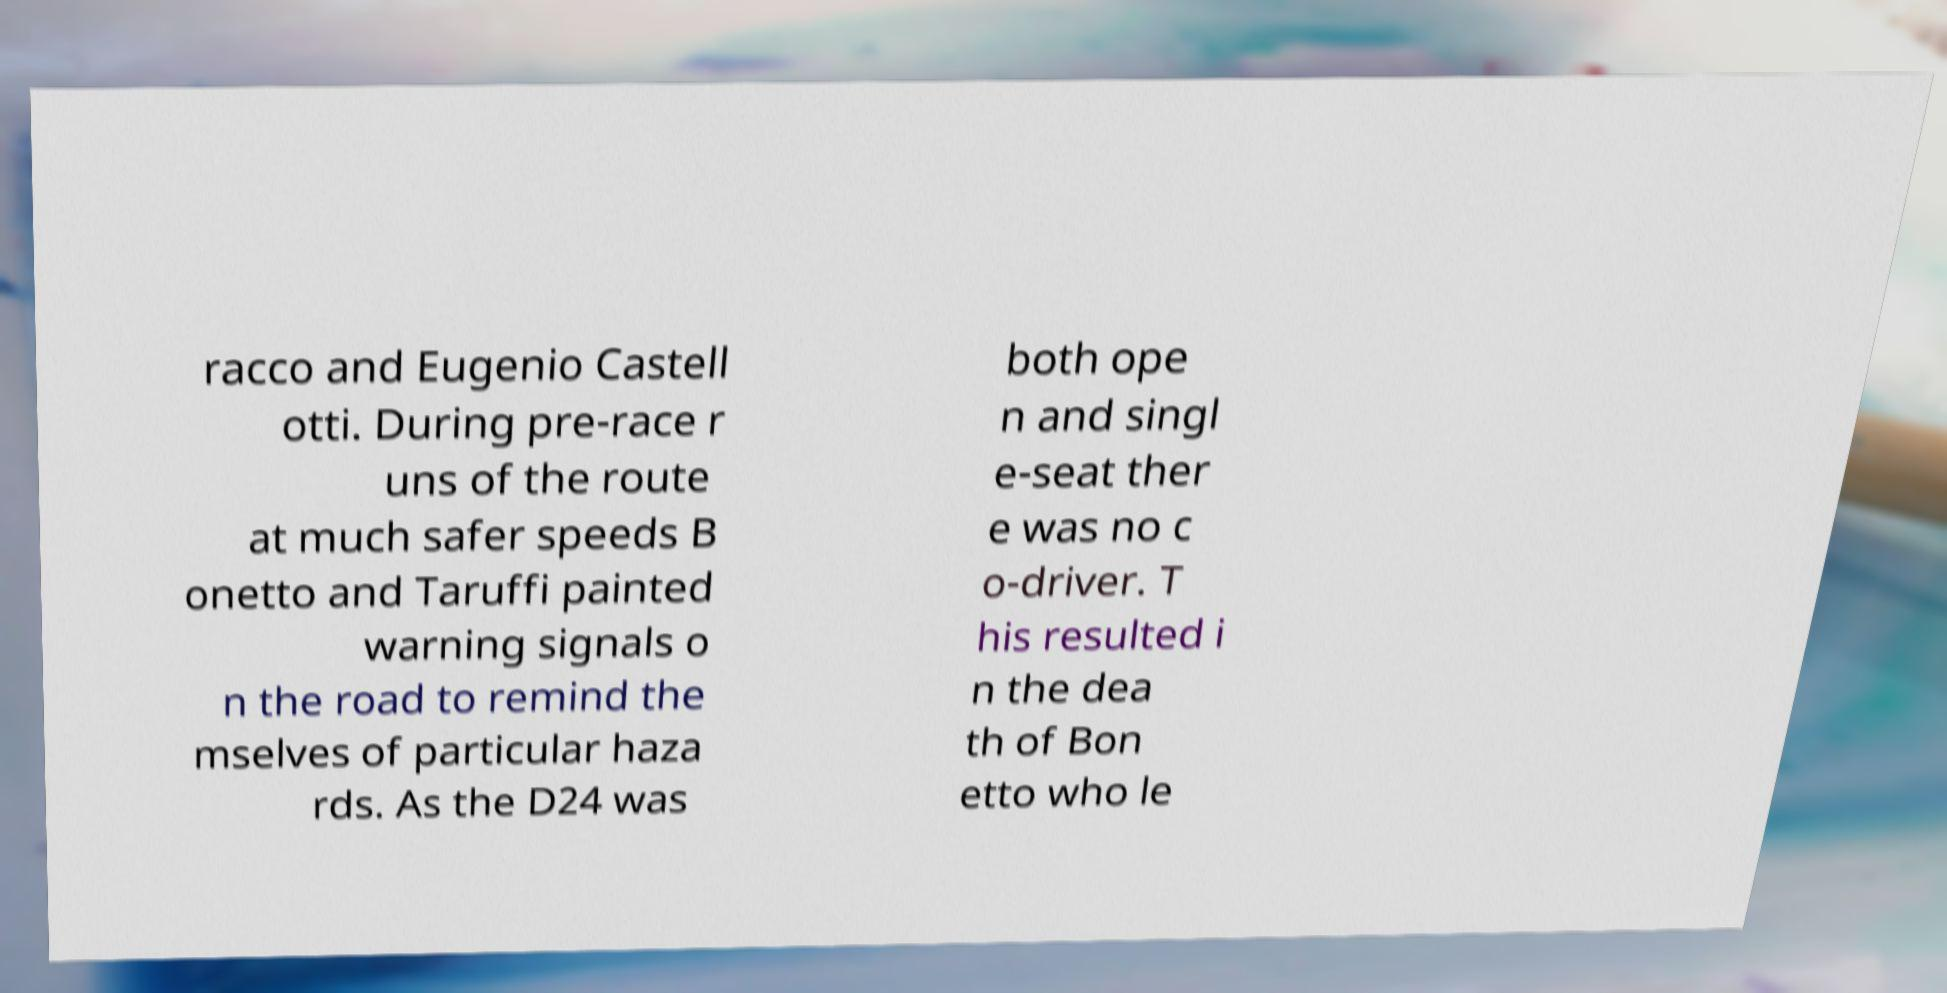Please identify and transcribe the text found in this image. racco and Eugenio Castell otti. During pre-race r uns of the route at much safer speeds B onetto and Taruffi painted warning signals o n the road to remind the mselves of particular haza rds. As the D24 was both ope n and singl e-seat ther e was no c o-driver. T his resulted i n the dea th of Bon etto who le 